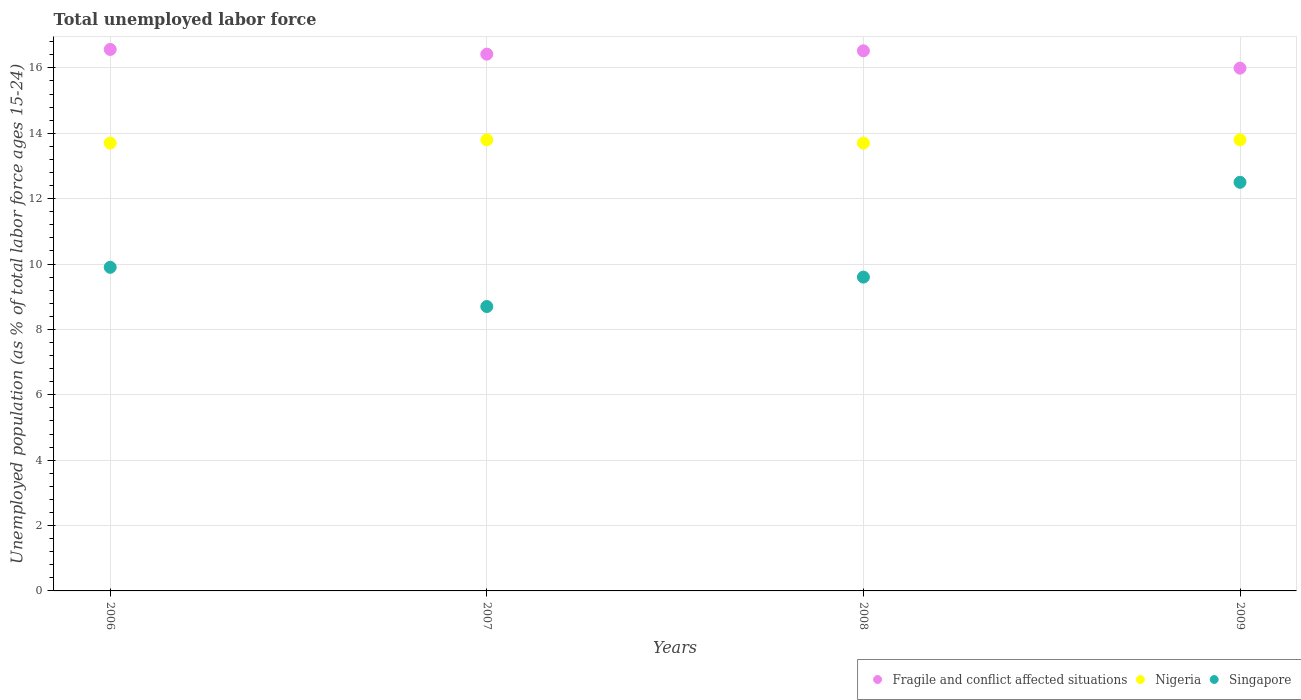Is the number of dotlines equal to the number of legend labels?
Offer a terse response. Yes. What is the percentage of unemployed population in in Fragile and conflict affected situations in 2009?
Your answer should be compact. 15.99. Across all years, what is the minimum percentage of unemployed population in in Fragile and conflict affected situations?
Your answer should be compact. 15.99. In which year was the percentage of unemployed population in in Singapore minimum?
Keep it short and to the point. 2007. What is the total percentage of unemployed population in in Singapore in the graph?
Your answer should be compact. 40.7. What is the difference between the percentage of unemployed population in in Fragile and conflict affected situations in 2006 and that in 2008?
Keep it short and to the point. 0.04. What is the difference between the percentage of unemployed population in in Singapore in 2006 and the percentage of unemployed population in in Fragile and conflict affected situations in 2009?
Provide a short and direct response. -6.09. What is the average percentage of unemployed population in in Fragile and conflict affected situations per year?
Provide a succinct answer. 16.38. In the year 2007, what is the difference between the percentage of unemployed population in in Singapore and percentage of unemployed population in in Nigeria?
Keep it short and to the point. -5.1. What is the ratio of the percentage of unemployed population in in Nigeria in 2006 to that in 2007?
Make the answer very short. 0.99. Is the percentage of unemployed population in in Singapore in 2006 less than that in 2007?
Provide a short and direct response. No. What is the difference between the highest and the second highest percentage of unemployed population in in Singapore?
Provide a short and direct response. 2.6. What is the difference between the highest and the lowest percentage of unemployed population in in Fragile and conflict affected situations?
Make the answer very short. 0.57. Is it the case that in every year, the sum of the percentage of unemployed population in in Nigeria and percentage of unemployed population in in Singapore  is greater than the percentage of unemployed population in in Fragile and conflict affected situations?
Provide a short and direct response. Yes. Does the percentage of unemployed population in in Nigeria monotonically increase over the years?
Your response must be concise. No. Is the percentage of unemployed population in in Nigeria strictly less than the percentage of unemployed population in in Fragile and conflict affected situations over the years?
Provide a short and direct response. Yes. How many dotlines are there?
Your answer should be very brief. 3. What is the difference between two consecutive major ticks on the Y-axis?
Offer a very short reply. 2. Are the values on the major ticks of Y-axis written in scientific E-notation?
Keep it short and to the point. No. Does the graph contain any zero values?
Give a very brief answer. No. Does the graph contain grids?
Your answer should be compact. Yes. What is the title of the graph?
Make the answer very short. Total unemployed labor force. What is the label or title of the X-axis?
Offer a very short reply. Years. What is the label or title of the Y-axis?
Offer a very short reply. Unemployed population (as % of total labor force ages 15-24). What is the Unemployed population (as % of total labor force ages 15-24) of Fragile and conflict affected situations in 2006?
Offer a very short reply. 16.57. What is the Unemployed population (as % of total labor force ages 15-24) in Nigeria in 2006?
Give a very brief answer. 13.7. What is the Unemployed population (as % of total labor force ages 15-24) of Singapore in 2006?
Your response must be concise. 9.9. What is the Unemployed population (as % of total labor force ages 15-24) of Fragile and conflict affected situations in 2007?
Offer a terse response. 16.42. What is the Unemployed population (as % of total labor force ages 15-24) in Nigeria in 2007?
Your answer should be compact. 13.8. What is the Unemployed population (as % of total labor force ages 15-24) of Singapore in 2007?
Provide a succinct answer. 8.7. What is the Unemployed population (as % of total labor force ages 15-24) of Fragile and conflict affected situations in 2008?
Offer a very short reply. 16.52. What is the Unemployed population (as % of total labor force ages 15-24) of Nigeria in 2008?
Your response must be concise. 13.7. What is the Unemployed population (as % of total labor force ages 15-24) of Singapore in 2008?
Provide a succinct answer. 9.6. What is the Unemployed population (as % of total labor force ages 15-24) of Fragile and conflict affected situations in 2009?
Your response must be concise. 15.99. What is the Unemployed population (as % of total labor force ages 15-24) of Nigeria in 2009?
Make the answer very short. 13.8. What is the Unemployed population (as % of total labor force ages 15-24) in Singapore in 2009?
Your answer should be very brief. 12.5. Across all years, what is the maximum Unemployed population (as % of total labor force ages 15-24) of Fragile and conflict affected situations?
Your response must be concise. 16.57. Across all years, what is the maximum Unemployed population (as % of total labor force ages 15-24) in Nigeria?
Offer a very short reply. 13.8. Across all years, what is the maximum Unemployed population (as % of total labor force ages 15-24) in Singapore?
Provide a succinct answer. 12.5. Across all years, what is the minimum Unemployed population (as % of total labor force ages 15-24) of Fragile and conflict affected situations?
Provide a short and direct response. 15.99. Across all years, what is the minimum Unemployed population (as % of total labor force ages 15-24) of Nigeria?
Ensure brevity in your answer.  13.7. Across all years, what is the minimum Unemployed population (as % of total labor force ages 15-24) of Singapore?
Provide a short and direct response. 8.7. What is the total Unemployed population (as % of total labor force ages 15-24) in Fragile and conflict affected situations in the graph?
Make the answer very short. 65.5. What is the total Unemployed population (as % of total labor force ages 15-24) of Singapore in the graph?
Your response must be concise. 40.7. What is the difference between the Unemployed population (as % of total labor force ages 15-24) in Fragile and conflict affected situations in 2006 and that in 2007?
Give a very brief answer. 0.14. What is the difference between the Unemployed population (as % of total labor force ages 15-24) of Singapore in 2006 and that in 2007?
Provide a succinct answer. 1.2. What is the difference between the Unemployed population (as % of total labor force ages 15-24) of Fragile and conflict affected situations in 2006 and that in 2008?
Your answer should be very brief. 0.04. What is the difference between the Unemployed population (as % of total labor force ages 15-24) of Nigeria in 2006 and that in 2008?
Ensure brevity in your answer.  0. What is the difference between the Unemployed population (as % of total labor force ages 15-24) of Singapore in 2006 and that in 2008?
Provide a short and direct response. 0.3. What is the difference between the Unemployed population (as % of total labor force ages 15-24) of Fragile and conflict affected situations in 2006 and that in 2009?
Give a very brief answer. 0.57. What is the difference between the Unemployed population (as % of total labor force ages 15-24) of Singapore in 2006 and that in 2009?
Keep it short and to the point. -2.6. What is the difference between the Unemployed population (as % of total labor force ages 15-24) of Fragile and conflict affected situations in 2007 and that in 2008?
Your answer should be compact. -0.1. What is the difference between the Unemployed population (as % of total labor force ages 15-24) of Fragile and conflict affected situations in 2007 and that in 2009?
Make the answer very short. 0.43. What is the difference between the Unemployed population (as % of total labor force ages 15-24) of Nigeria in 2007 and that in 2009?
Your response must be concise. 0. What is the difference between the Unemployed population (as % of total labor force ages 15-24) in Fragile and conflict affected situations in 2008 and that in 2009?
Give a very brief answer. 0.53. What is the difference between the Unemployed population (as % of total labor force ages 15-24) of Nigeria in 2008 and that in 2009?
Give a very brief answer. -0.1. What is the difference between the Unemployed population (as % of total labor force ages 15-24) in Fragile and conflict affected situations in 2006 and the Unemployed population (as % of total labor force ages 15-24) in Nigeria in 2007?
Offer a terse response. 2.77. What is the difference between the Unemployed population (as % of total labor force ages 15-24) in Fragile and conflict affected situations in 2006 and the Unemployed population (as % of total labor force ages 15-24) in Singapore in 2007?
Keep it short and to the point. 7.87. What is the difference between the Unemployed population (as % of total labor force ages 15-24) in Nigeria in 2006 and the Unemployed population (as % of total labor force ages 15-24) in Singapore in 2007?
Provide a short and direct response. 5. What is the difference between the Unemployed population (as % of total labor force ages 15-24) in Fragile and conflict affected situations in 2006 and the Unemployed population (as % of total labor force ages 15-24) in Nigeria in 2008?
Give a very brief answer. 2.87. What is the difference between the Unemployed population (as % of total labor force ages 15-24) of Fragile and conflict affected situations in 2006 and the Unemployed population (as % of total labor force ages 15-24) of Singapore in 2008?
Provide a succinct answer. 6.97. What is the difference between the Unemployed population (as % of total labor force ages 15-24) of Fragile and conflict affected situations in 2006 and the Unemployed population (as % of total labor force ages 15-24) of Nigeria in 2009?
Your response must be concise. 2.77. What is the difference between the Unemployed population (as % of total labor force ages 15-24) in Fragile and conflict affected situations in 2006 and the Unemployed population (as % of total labor force ages 15-24) in Singapore in 2009?
Keep it short and to the point. 4.07. What is the difference between the Unemployed population (as % of total labor force ages 15-24) in Nigeria in 2006 and the Unemployed population (as % of total labor force ages 15-24) in Singapore in 2009?
Ensure brevity in your answer.  1.2. What is the difference between the Unemployed population (as % of total labor force ages 15-24) in Fragile and conflict affected situations in 2007 and the Unemployed population (as % of total labor force ages 15-24) in Nigeria in 2008?
Provide a short and direct response. 2.72. What is the difference between the Unemployed population (as % of total labor force ages 15-24) in Fragile and conflict affected situations in 2007 and the Unemployed population (as % of total labor force ages 15-24) in Singapore in 2008?
Offer a terse response. 6.82. What is the difference between the Unemployed population (as % of total labor force ages 15-24) in Nigeria in 2007 and the Unemployed population (as % of total labor force ages 15-24) in Singapore in 2008?
Keep it short and to the point. 4.2. What is the difference between the Unemployed population (as % of total labor force ages 15-24) in Fragile and conflict affected situations in 2007 and the Unemployed population (as % of total labor force ages 15-24) in Nigeria in 2009?
Give a very brief answer. 2.62. What is the difference between the Unemployed population (as % of total labor force ages 15-24) of Fragile and conflict affected situations in 2007 and the Unemployed population (as % of total labor force ages 15-24) of Singapore in 2009?
Give a very brief answer. 3.92. What is the difference between the Unemployed population (as % of total labor force ages 15-24) in Nigeria in 2007 and the Unemployed population (as % of total labor force ages 15-24) in Singapore in 2009?
Provide a succinct answer. 1.3. What is the difference between the Unemployed population (as % of total labor force ages 15-24) of Fragile and conflict affected situations in 2008 and the Unemployed population (as % of total labor force ages 15-24) of Nigeria in 2009?
Offer a very short reply. 2.72. What is the difference between the Unemployed population (as % of total labor force ages 15-24) of Fragile and conflict affected situations in 2008 and the Unemployed population (as % of total labor force ages 15-24) of Singapore in 2009?
Provide a succinct answer. 4.02. What is the difference between the Unemployed population (as % of total labor force ages 15-24) of Nigeria in 2008 and the Unemployed population (as % of total labor force ages 15-24) of Singapore in 2009?
Your answer should be compact. 1.2. What is the average Unemployed population (as % of total labor force ages 15-24) of Fragile and conflict affected situations per year?
Your answer should be compact. 16.38. What is the average Unemployed population (as % of total labor force ages 15-24) of Nigeria per year?
Offer a very short reply. 13.75. What is the average Unemployed population (as % of total labor force ages 15-24) in Singapore per year?
Make the answer very short. 10.18. In the year 2006, what is the difference between the Unemployed population (as % of total labor force ages 15-24) of Fragile and conflict affected situations and Unemployed population (as % of total labor force ages 15-24) of Nigeria?
Provide a succinct answer. 2.87. In the year 2006, what is the difference between the Unemployed population (as % of total labor force ages 15-24) of Fragile and conflict affected situations and Unemployed population (as % of total labor force ages 15-24) of Singapore?
Give a very brief answer. 6.67. In the year 2007, what is the difference between the Unemployed population (as % of total labor force ages 15-24) of Fragile and conflict affected situations and Unemployed population (as % of total labor force ages 15-24) of Nigeria?
Your answer should be very brief. 2.62. In the year 2007, what is the difference between the Unemployed population (as % of total labor force ages 15-24) in Fragile and conflict affected situations and Unemployed population (as % of total labor force ages 15-24) in Singapore?
Provide a succinct answer. 7.72. In the year 2007, what is the difference between the Unemployed population (as % of total labor force ages 15-24) of Nigeria and Unemployed population (as % of total labor force ages 15-24) of Singapore?
Make the answer very short. 5.1. In the year 2008, what is the difference between the Unemployed population (as % of total labor force ages 15-24) in Fragile and conflict affected situations and Unemployed population (as % of total labor force ages 15-24) in Nigeria?
Your answer should be compact. 2.82. In the year 2008, what is the difference between the Unemployed population (as % of total labor force ages 15-24) of Fragile and conflict affected situations and Unemployed population (as % of total labor force ages 15-24) of Singapore?
Provide a succinct answer. 6.92. In the year 2008, what is the difference between the Unemployed population (as % of total labor force ages 15-24) of Nigeria and Unemployed population (as % of total labor force ages 15-24) of Singapore?
Your answer should be compact. 4.1. In the year 2009, what is the difference between the Unemployed population (as % of total labor force ages 15-24) of Fragile and conflict affected situations and Unemployed population (as % of total labor force ages 15-24) of Nigeria?
Ensure brevity in your answer.  2.19. In the year 2009, what is the difference between the Unemployed population (as % of total labor force ages 15-24) in Fragile and conflict affected situations and Unemployed population (as % of total labor force ages 15-24) in Singapore?
Your response must be concise. 3.49. In the year 2009, what is the difference between the Unemployed population (as % of total labor force ages 15-24) of Nigeria and Unemployed population (as % of total labor force ages 15-24) of Singapore?
Ensure brevity in your answer.  1.3. What is the ratio of the Unemployed population (as % of total labor force ages 15-24) in Fragile and conflict affected situations in 2006 to that in 2007?
Provide a succinct answer. 1.01. What is the ratio of the Unemployed population (as % of total labor force ages 15-24) of Nigeria in 2006 to that in 2007?
Keep it short and to the point. 0.99. What is the ratio of the Unemployed population (as % of total labor force ages 15-24) of Singapore in 2006 to that in 2007?
Your answer should be compact. 1.14. What is the ratio of the Unemployed population (as % of total labor force ages 15-24) of Fragile and conflict affected situations in 2006 to that in 2008?
Provide a succinct answer. 1. What is the ratio of the Unemployed population (as % of total labor force ages 15-24) of Singapore in 2006 to that in 2008?
Your response must be concise. 1.03. What is the ratio of the Unemployed population (as % of total labor force ages 15-24) in Fragile and conflict affected situations in 2006 to that in 2009?
Offer a very short reply. 1.04. What is the ratio of the Unemployed population (as % of total labor force ages 15-24) in Nigeria in 2006 to that in 2009?
Your response must be concise. 0.99. What is the ratio of the Unemployed population (as % of total labor force ages 15-24) of Singapore in 2006 to that in 2009?
Your answer should be very brief. 0.79. What is the ratio of the Unemployed population (as % of total labor force ages 15-24) of Nigeria in 2007 to that in 2008?
Ensure brevity in your answer.  1.01. What is the ratio of the Unemployed population (as % of total labor force ages 15-24) of Singapore in 2007 to that in 2008?
Your response must be concise. 0.91. What is the ratio of the Unemployed population (as % of total labor force ages 15-24) in Fragile and conflict affected situations in 2007 to that in 2009?
Your answer should be very brief. 1.03. What is the ratio of the Unemployed population (as % of total labor force ages 15-24) in Nigeria in 2007 to that in 2009?
Offer a terse response. 1. What is the ratio of the Unemployed population (as % of total labor force ages 15-24) in Singapore in 2007 to that in 2009?
Offer a terse response. 0.7. What is the ratio of the Unemployed population (as % of total labor force ages 15-24) of Fragile and conflict affected situations in 2008 to that in 2009?
Offer a very short reply. 1.03. What is the ratio of the Unemployed population (as % of total labor force ages 15-24) in Nigeria in 2008 to that in 2009?
Make the answer very short. 0.99. What is the ratio of the Unemployed population (as % of total labor force ages 15-24) in Singapore in 2008 to that in 2009?
Give a very brief answer. 0.77. What is the difference between the highest and the second highest Unemployed population (as % of total labor force ages 15-24) in Fragile and conflict affected situations?
Provide a short and direct response. 0.04. What is the difference between the highest and the second highest Unemployed population (as % of total labor force ages 15-24) in Nigeria?
Offer a terse response. 0. What is the difference between the highest and the second highest Unemployed population (as % of total labor force ages 15-24) in Singapore?
Your answer should be compact. 2.6. What is the difference between the highest and the lowest Unemployed population (as % of total labor force ages 15-24) in Fragile and conflict affected situations?
Your response must be concise. 0.57. 